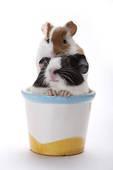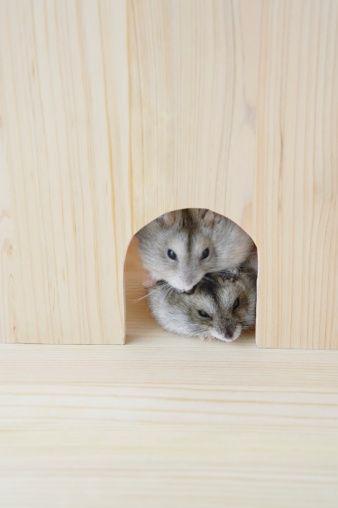The first image is the image on the left, the second image is the image on the right. Analyze the images presented: Is the assertion "Each image contains multiple pet rodents, and at least one image shows two rodents posed so one has its head directly above the other." valid? Answer yes or no. Yes. 